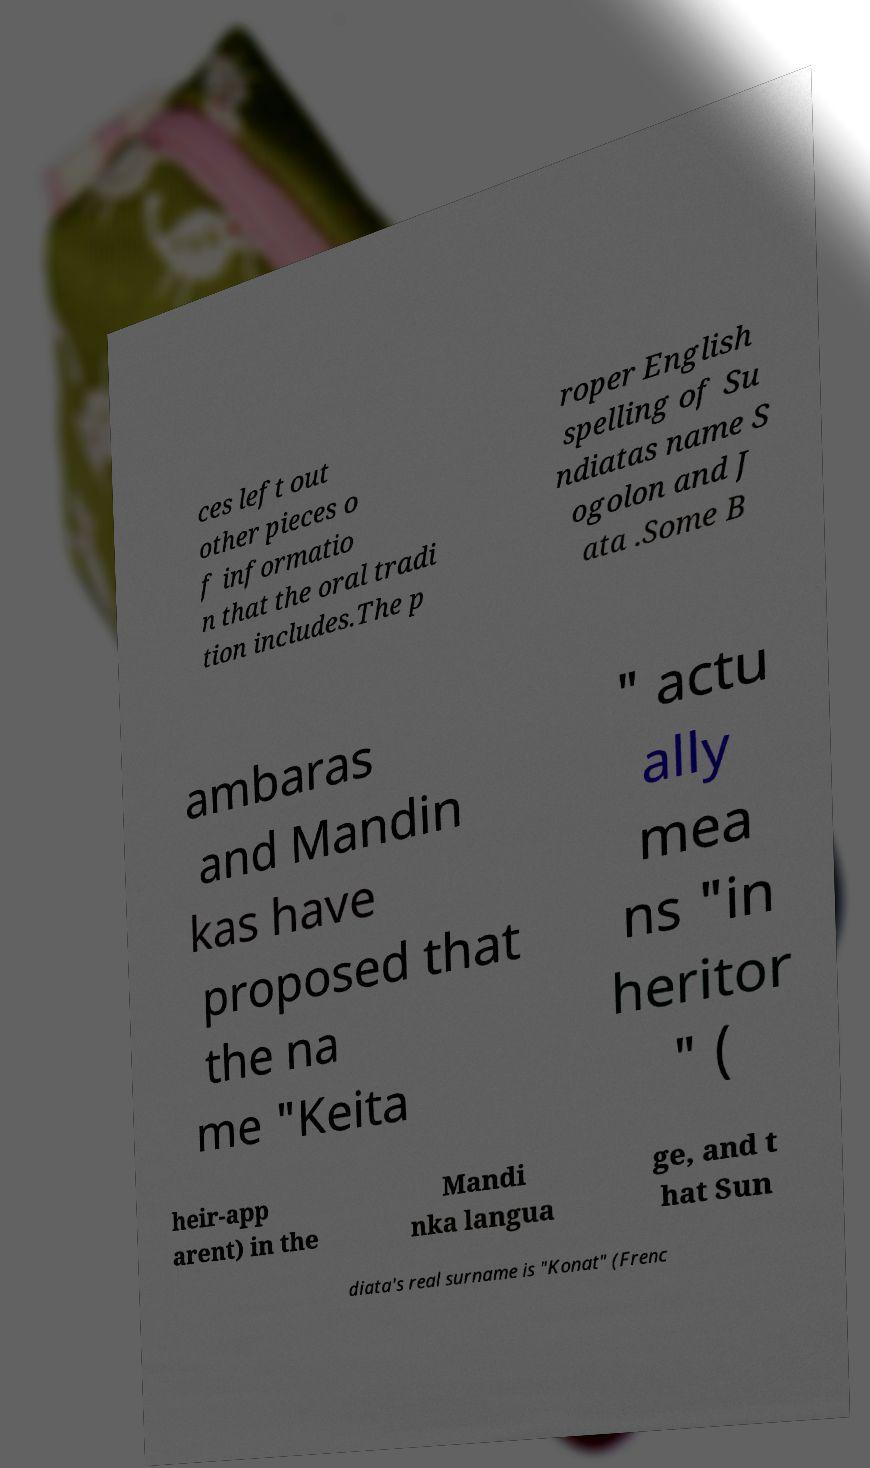Can you read and provide the text displayed in the image?This photo seems to have some interesting text. Can you extract and type it out for me? ces left out other pieces o f informatio n that the oral tradi tion includes.The p roper English spelling of Su ndiatas name S ogolon and J ata .Some B ambaras and Mandin kas have proposed that the na me "Keita " actu ally mea ns "in heritor " ( heir-app arent) in the Mandi nka langua ge, and t hat Sun diata's real surname is "Konat" (Frenc 